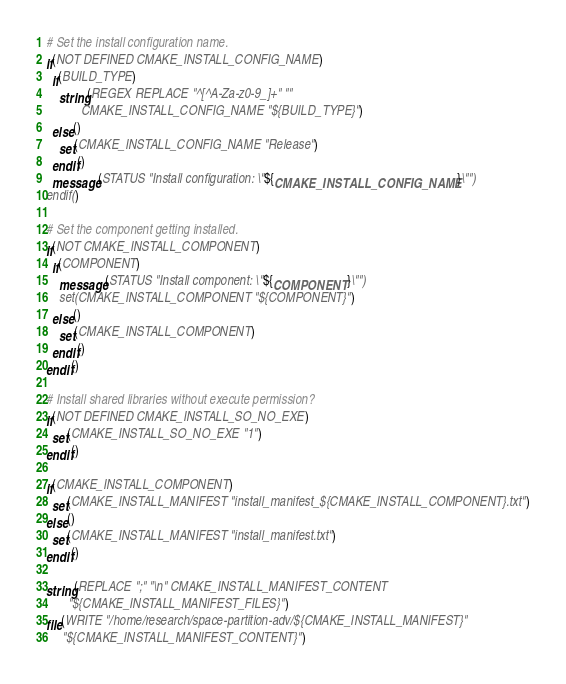<code> <loc_0><loc_0><loc_500><loc_500><_CMake_># Set the install configuration name.
if(NOT DEFINED CMAKE_INSTALL_CONFIG_NAME)
  if(BUILD_TYPE)
    string(REGEX REPLACE "^[^A-Za-z0-9_]+" ""
           CMAKE_INSTALL_CONFIG_NAME "${BUILD_TYPE}")
  else()
    set(CMAKE_INSTALL_CONFIG_NAME "Release")
  endif()
  message(STATUS "Install configuration: \"${CMAKE_INSTALL_CONFIG_NAME}\"")
endif()

# Set the component getting installed.
if(NOT CMAKE_INSTALL_COMPONENT)
  if(COMPONENT)
    message(STATUS "Install component: \"${COMPONENT}\"")
    set(CMAKE_INSTALL_COMPONENT "${COMPONENT}")
  else()
    set(CMAKE_INSTALL_COMPONENT)
  endif()
endif()

# Install shared libraries without execute permission?
if(NOT DEFINED CMAKE_INSTALL_SO_NO_EXE)
  set(CMAKE_INSTALL_SO_NO_EXE "1")
endif()

if(CMAKE_INSTALL_COMPONENT)
  set(CMAKE_INSTALL_MANIFEST "install_manifest_${CMAKE_INSTALL_COMPONENT}.txt")
else()
  set(CMAKE_INSTALL_MANIFEST "install_manifest.txt")
endif()

string(REPLACE ";" "\n" CMAKE_INSTALL_MANIFEST_CONTENT
       "${CMAKE_INSTALL_MANIFEST_FILES}")
file(WRITE "/home/research/space-partition-adv/${CMAKE_INSTALL_MANIFEST}"
     "${CMAKE_INSTALL_MANIFEST_CONTENT}")
</code> 